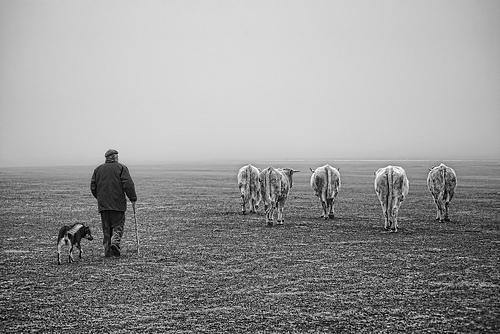How many cows are to the left of the man?
Give a very brief answer. 0. 